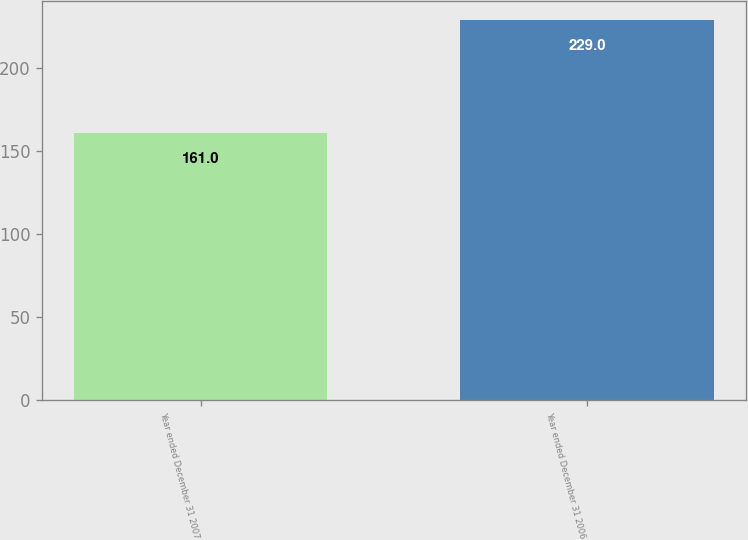<chart> <loc_0><loc_0><loc_500><loc_500><bar_chart><fcel>Year ended December 31 2007<fcel>Year ended December 31 2006<nl><fcel>161<fcel>229<nl></chart> 